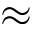Convert formula to latex. <formula><loc_0><loc_0><loc_500><loc_500>\approx</formula> 